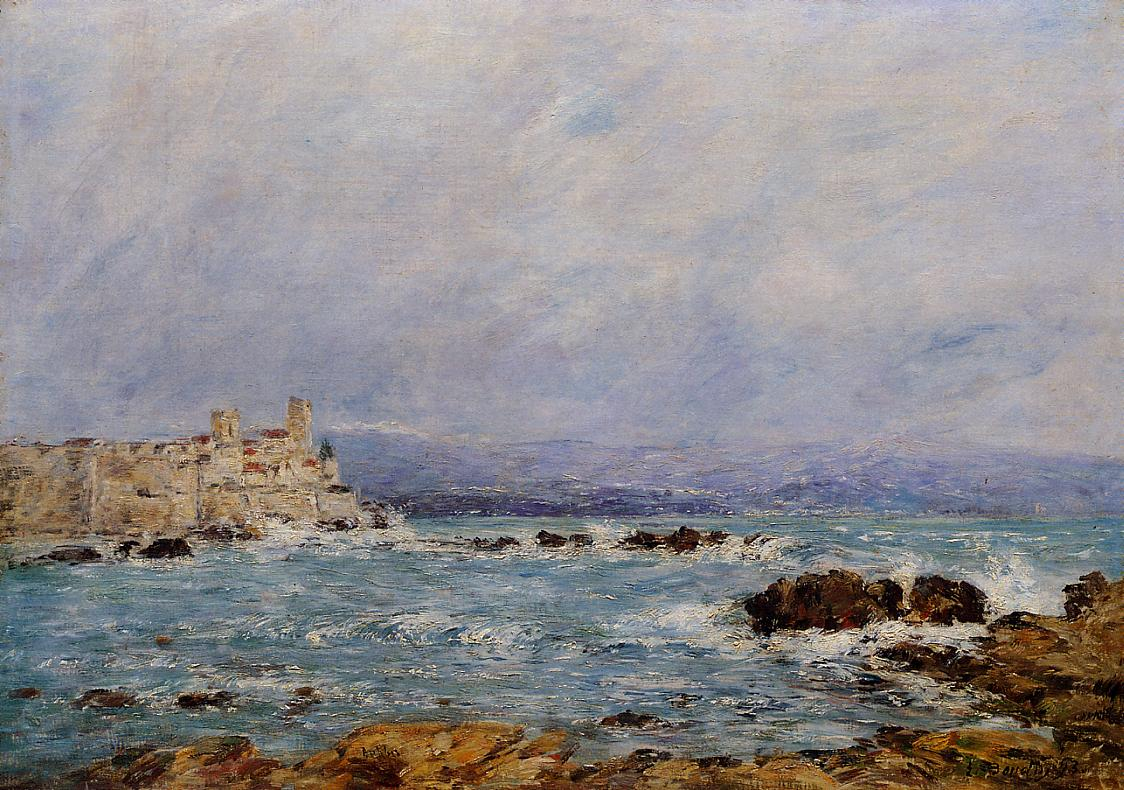What emotions does the painting evoke in you? The painting evokes a sense of calm and serenity. The tranquil blue sky filled with soft, wispy clouds and the gently lapping waves against the rocky coastline create a harmonious and peaceful mood. The distant castle perched on the cliff adds a touch of nostalgia and timelessness to the scene, inviting viewers to reflect on the passage of time and the beauty of nature. How do you think the artist captured the essence of the seaside? The artist captured the essence of the seaside through his masterful use of color and brushwork. The dark green hue of the moss-covered rocks implies a rugged coastline, while the darker blue sea with whitecaps conveys the restless and ever-changing nature of the ocean. The light beige castle standing on the cliff adds a historical and romantic element to the composition. Monet's signature brushstrokes create a sense of movement and atmosphere, encapsulating the sensory experience of being by the sea. Imagine if the castle could talk, what stories it might tell? If the castle could talk, it might tell stories of ancient seafarers and epic battles fought at sea. It might whisper about the many sunsets it has witnessed, casting its golden glow across the water and the tales of lovers who have stood on its walls, dreaming under star-filled skies. The castle could reveal legends of hidden treasures and ghostly apparitions, making it a place rich with history and mystery. Its weather-beaten stones would speak of resilience and the passage of time, standing tall through centuries of change and natural forces. 